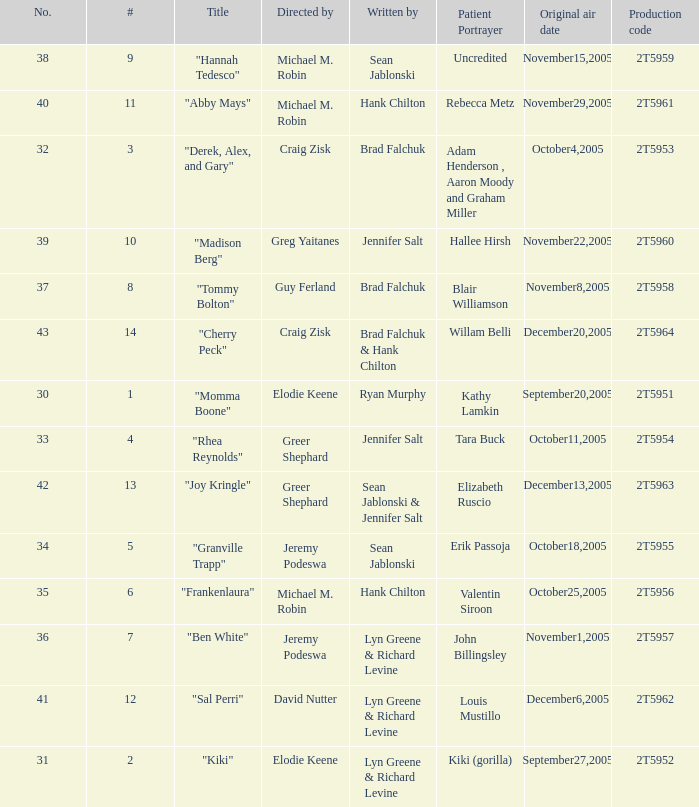What is the production code for the episode where the patient portrayer is Kathy Lamkin? 2T5951. 